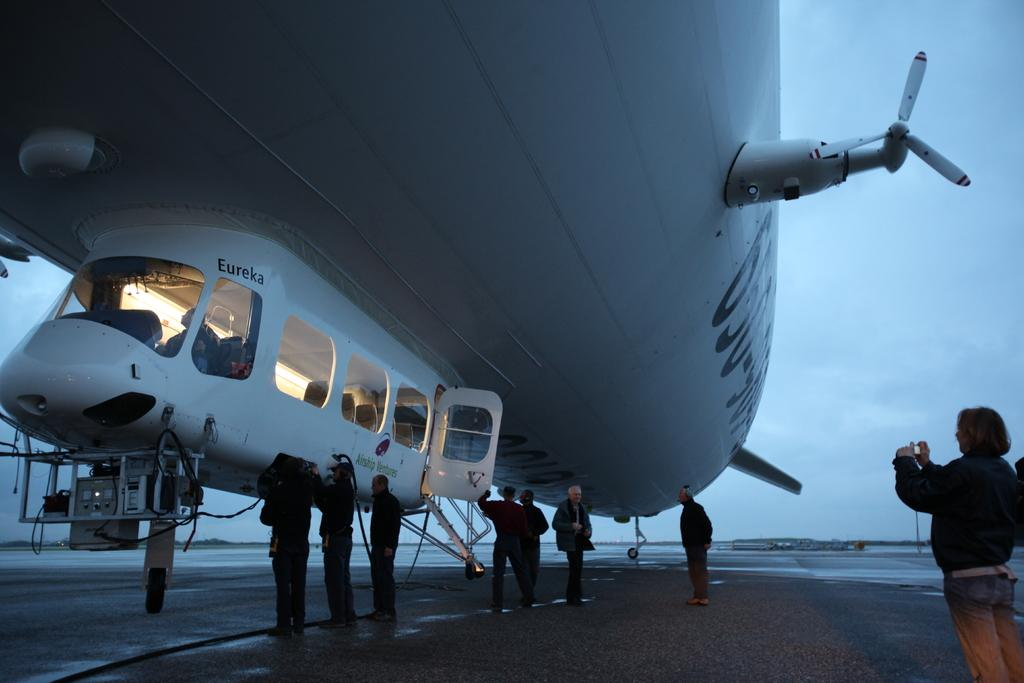What is the main subject in the center of the image? There is an aeroplane in the center of the image. What else can be seen at the bottom of the image? There are persons at the bottom of the image. What is visible in the background of the image? There is a sky visible in the background of the image. What type of berry can be seen hanging from the aeroplane in the image? There is no berry present in the image, and it is not hanging from the aeroplane. 